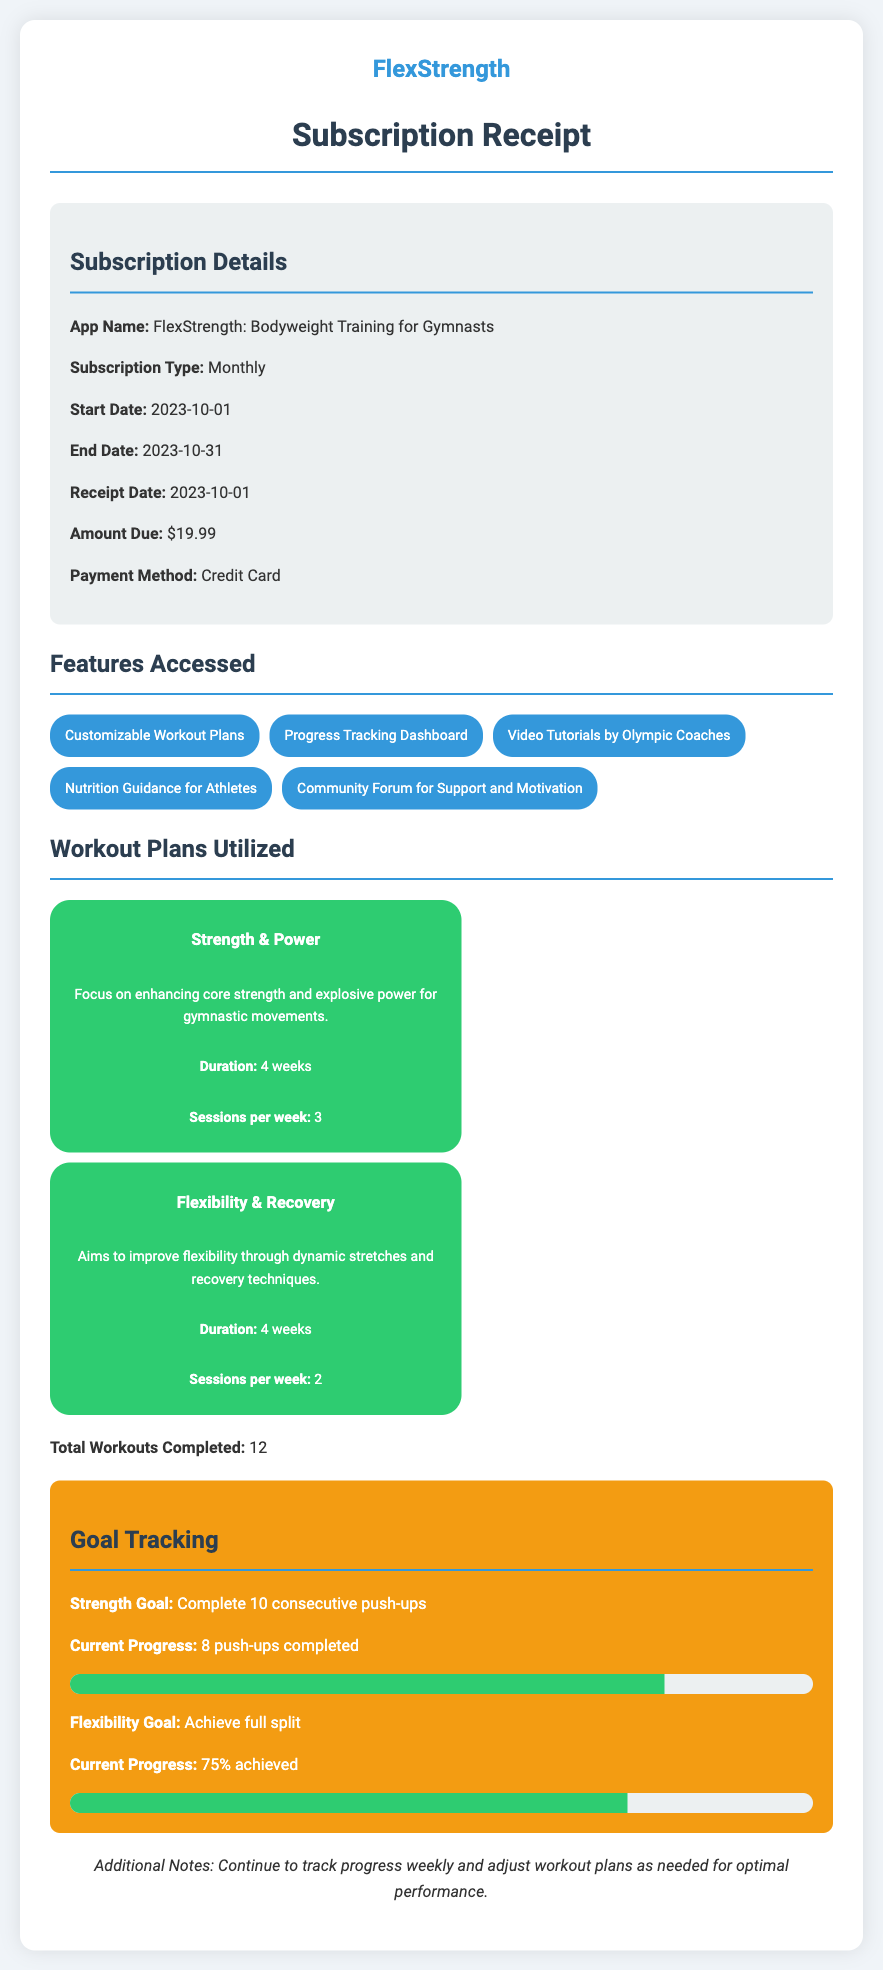What is the app name? The app name is explicitly stated in the subscription details section of the document.
Answer: FlexStrength: Bodyweight Training for Gymnasts What is the subscription type? The subscription type can be found under the subscription details section, outlining how the subscription is billed.
Answer: Monthly What is the amount due for the subscription? The amount due is mentioned clearly in the receipt details section as the cost of the subscription.
Answer: $19.99 How many sessions per week are recommended for the Strength & Power plan? The number of sessions per week for the Strength & Power plan is specified within its description in the workout plans utilized section.
Answer: 3 What is the current progress towards the flexibility goal? The current progress toward the flexibility goal is noted in the goal tracking section, indicating how close the user is to achieving their objective.
Answer: 75% achieved What is the duration of the Flexibility & Recovery plan? The duration of the Flexibility & Recovery plan is highlighted in its description within the workout plans utilized section.
Answer: 4 weeks What feature provides video tutorials? The feature that provides video tutorials is explicitly listed in the features accessed section of the document.
Answer: Video Tutorials by Olympic Coaches What is the start date of the subscription? The start date of the subscription is mentioned in the subscription details section, marking the beginning of the billing period.
Answer: 2023-10-01 What additional notes are provided? The additional notes section gives insight into recommendations for the user, summarizing helpful advice for ongoing use.
Answer: Continue to track progress weekly and adjust workout plans as needed for optimal performance 